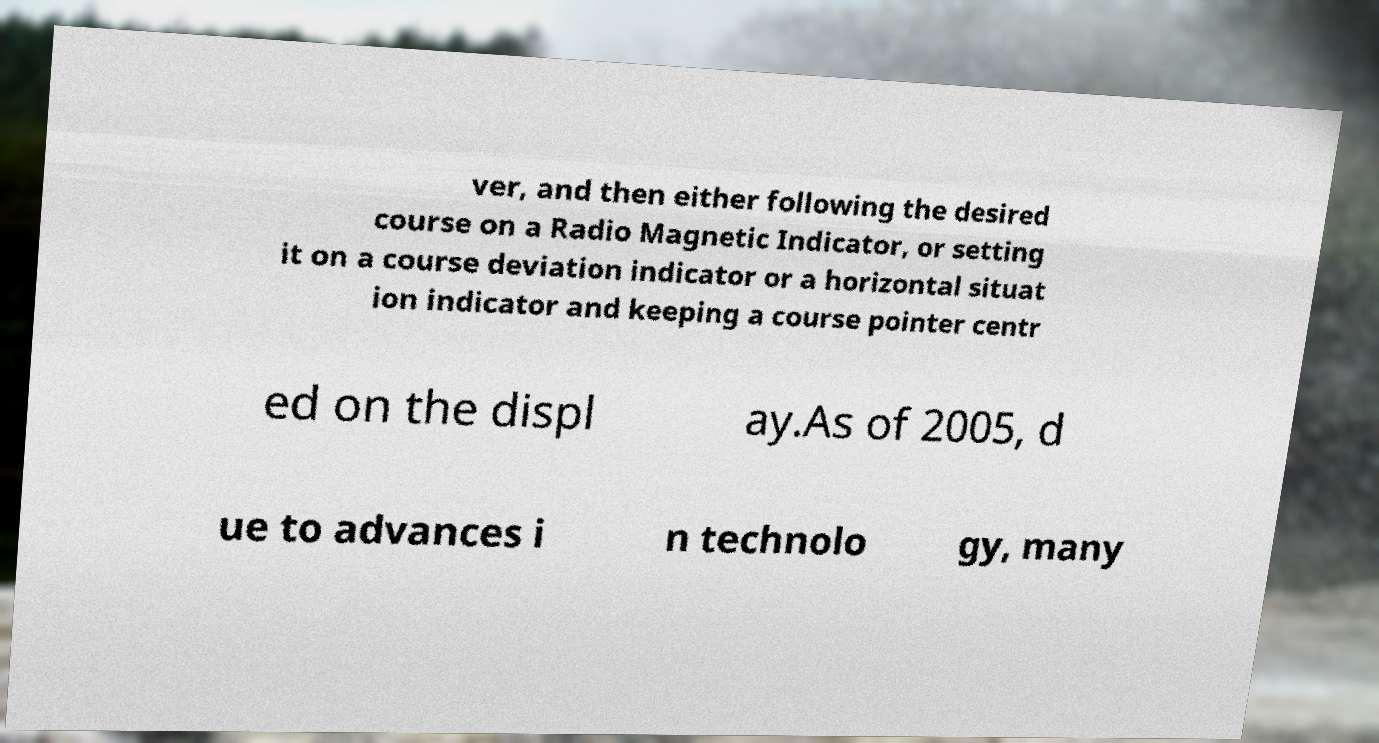I need the written content from this picture converted into text. Can you do that? ver, and then either following the desired course on a Radio Magnetic Indicator, or setting it on a course deviation indicator or a horizontal situat ion indicator and keeping a course pointer centr ed on the displ ay.As of 2005, d ue to advances i n technolo gy, many 